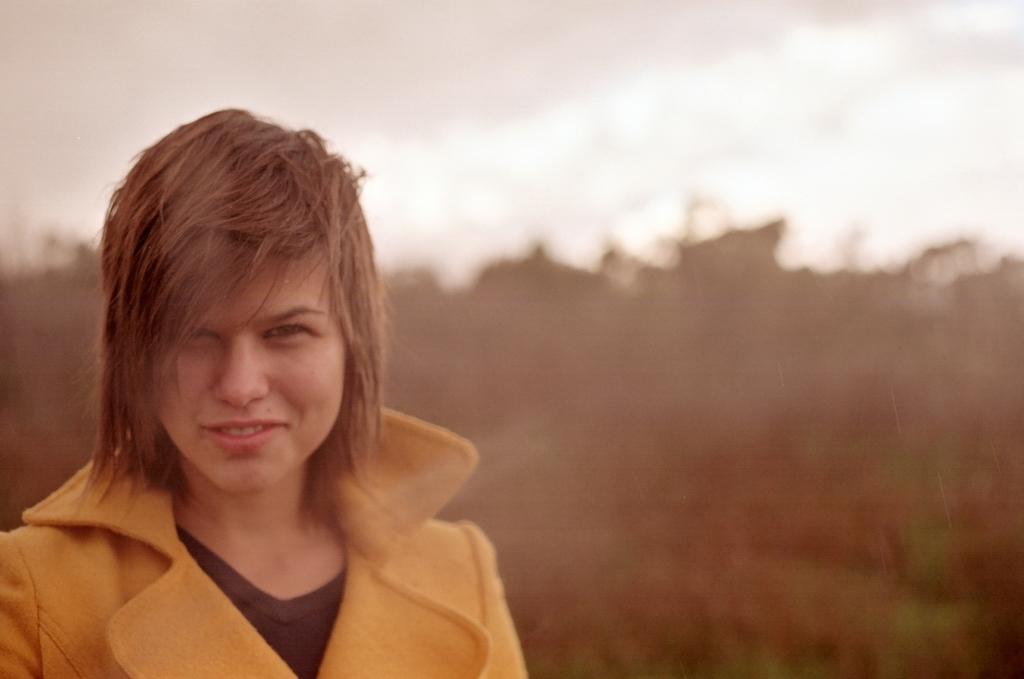Describe this image in one or two sentences. In this image we can see women. In the background we can see trees, and sky. 